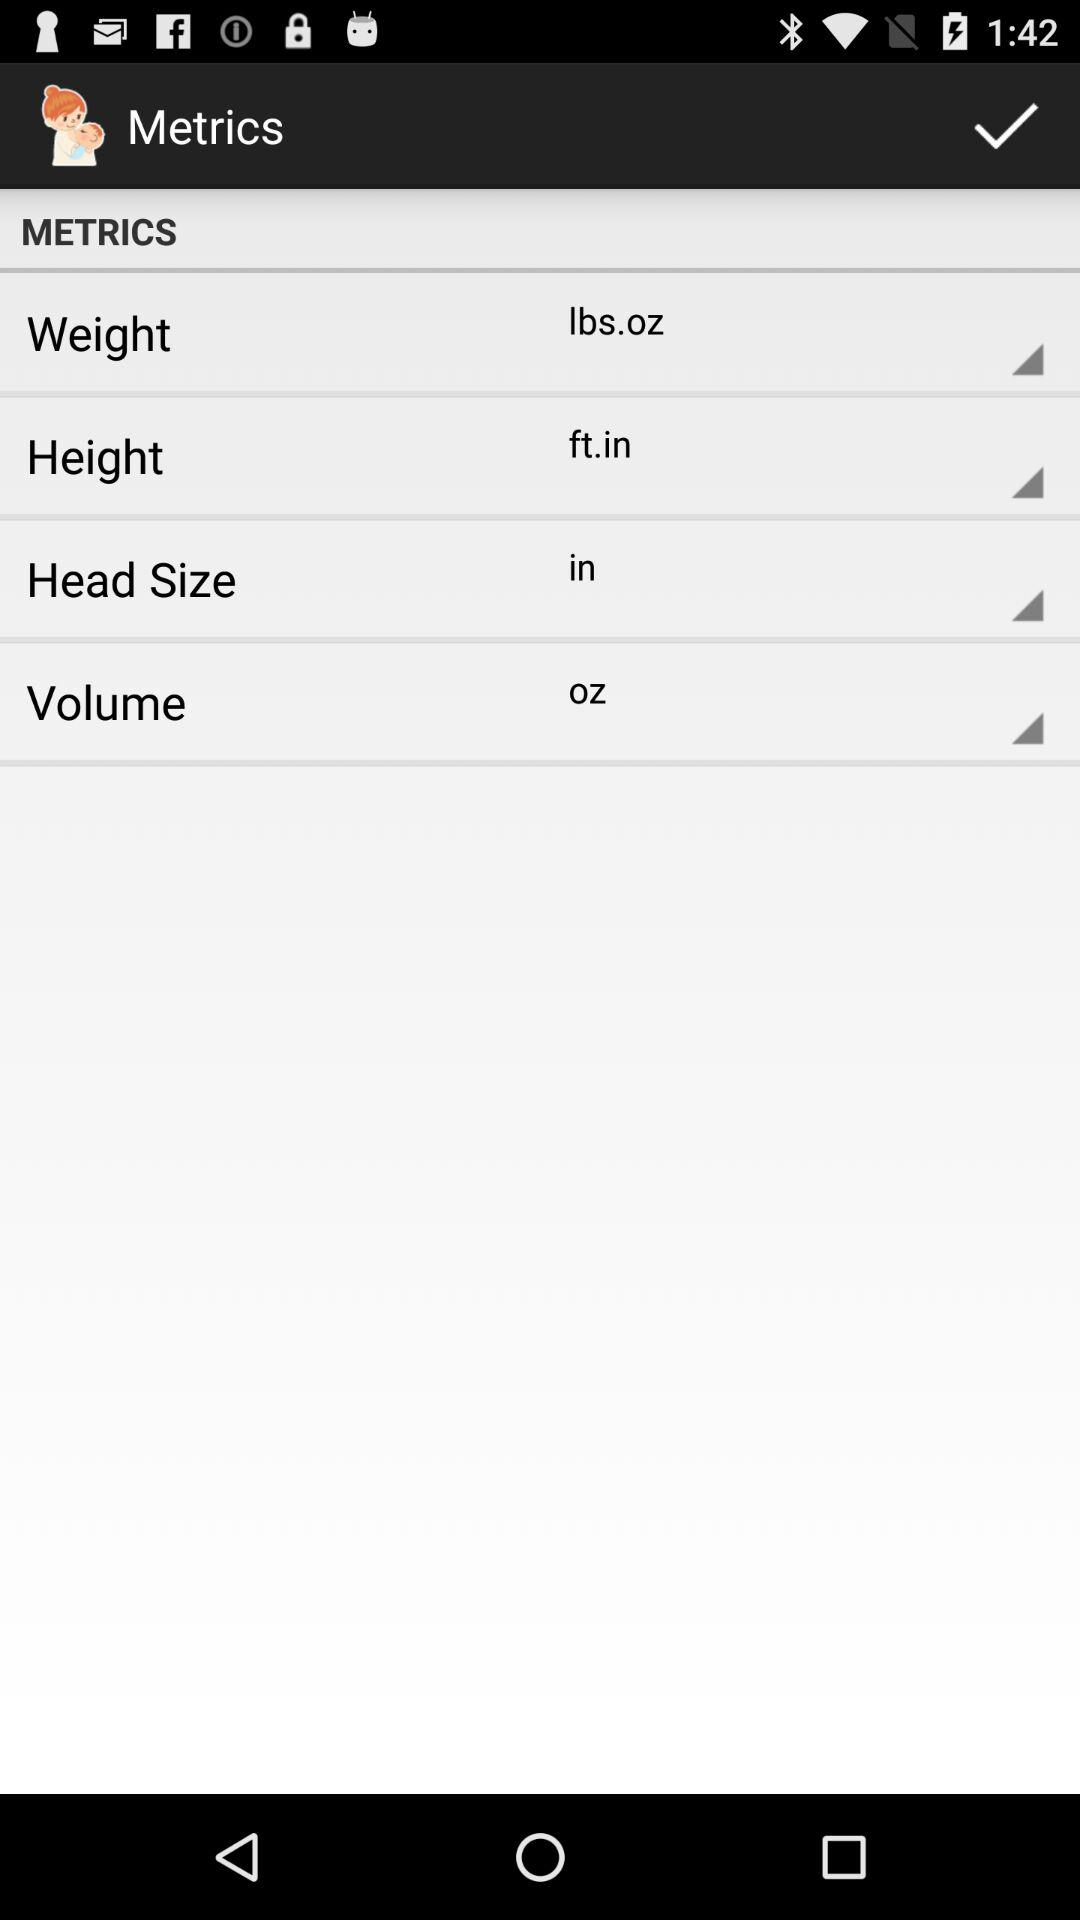What is the unit of volume? The unit of volume is ounces. 